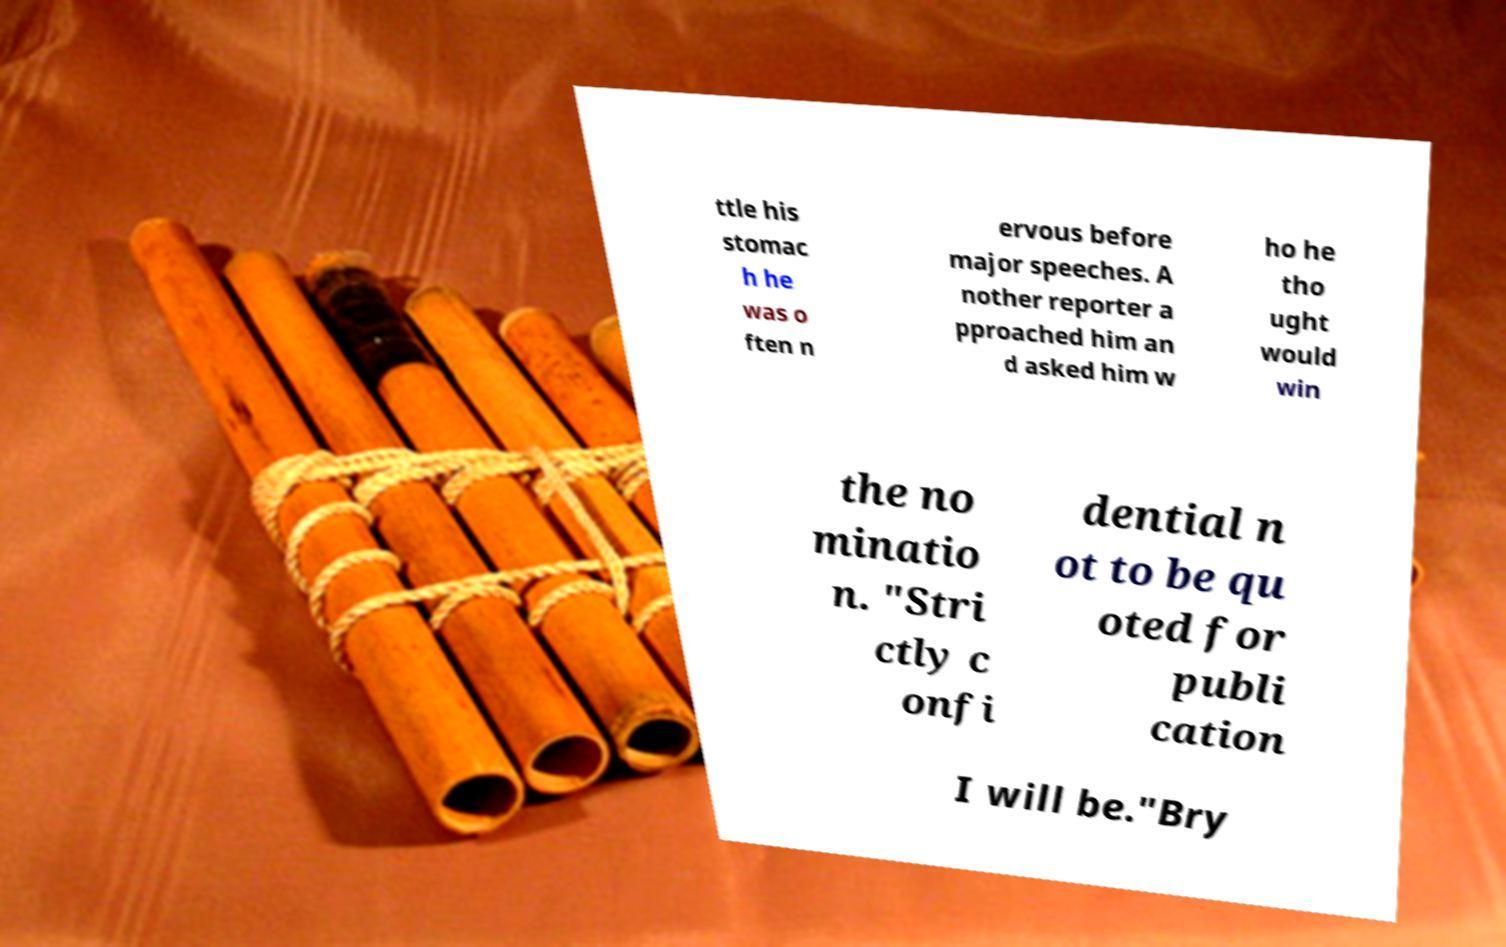Can you read and provide the text displayed in the image?This photo seems to have some interesting text. Can you extract and type it out for me? ttle his stomac h he was o ften n ervous before major speeches. A nother reporter a pproached him an d asked him w ho he tho ught would win the no minatio n. "Stri ctly c onfi dential n ot to be qu oted for publi cation I will be."Bry 